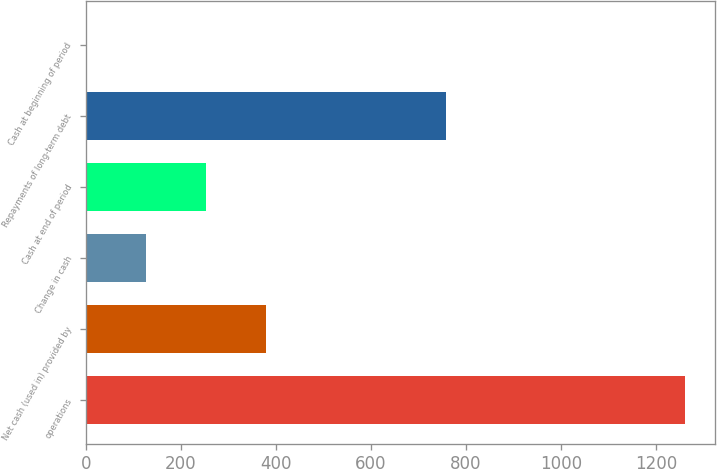Convert chart to OTSL. <chart><loc_0><loc_0><loc_500><loc_500><bar_chart><fcel>operations<fcel>Net cash (used in) provided by<fcel>Change in cash<fcel>Cash at end of period<fcel>Repayments of long-term debt<fcel>Cash at beginning of period<nl><fcel>1262<fcel>380<fcel>128<fcel>254<fcel>758<fcel>2<nl></chart> 